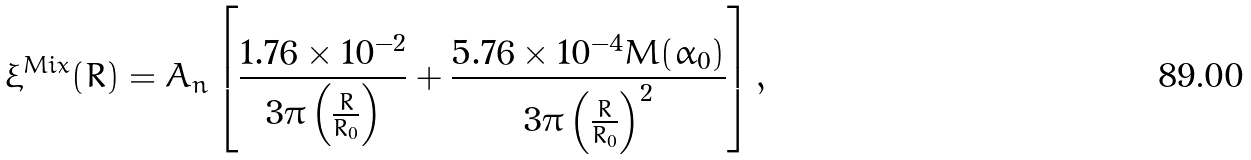Convert formula to latex. <formula><loc_0><loc_0><loc_500><loc_500>\xi ^ { M i x } ( R ) = A _ { n } \left [ \frac { 1 . 7 6 \times 1 0 ^ { - 2 } } { 3 \pi \left ( \frac { R } { R _ { 0 } } \right ) } + \frac { 5 . 7 6 \times 1 0 ^ { - 4 } M ( \alpha _ { 0 } ) } { 3 \pi \left ( \frac { R } { R _ { 0 } } \right ) ^ { 2 } } \right ] ,</formula> 